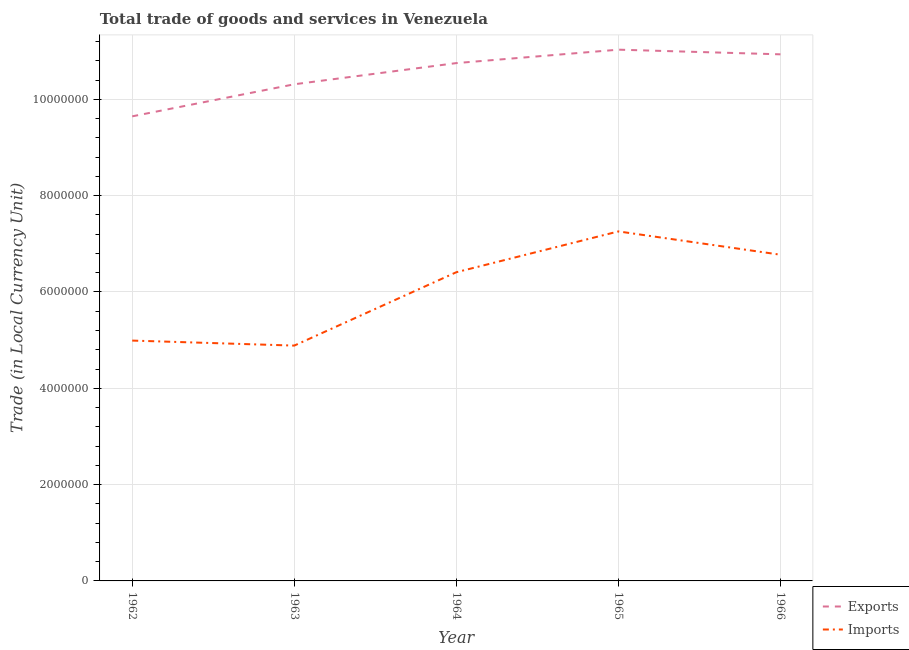Does the line corresponding to export of goods and services intersect with the line corresponding to imports of goods and services?
Your response must be concise. No. What is the export of goods and services in 1965?
Give a very brief answer. 1.10e+07. Across all years, what is the maximum export of goods and services?
Keep it short and to the point. 1.10e+07. Across all years, what is the minimum export of goods and services?
Your answer should be very brief. 9.65e+06. In which year was the export of goods and services maximum?
Your response must be concise. 1965. In which year was the export of goods and services minimum?
Keep it short and to the point. 1962. What is the total export of goods and services in the graph?
Give a very brief answer. 5.27e+07. What is the difference between the imports of goods and services in 1963 and that in 1965?
Provide a succinct answer. -2.37e+06. What is the difference between the imports of goods and services in 1966 and the export of goods and services in 1962?
Give a very brief answer. -2.87e+06. What is the average export of goods and services per year?
Provide a succinct answer. 1.05e+07. In the year 1964, what is the difference between the imports of goods and services and export of goods and services?
Offer a terse response. -4.34e+06. What is the ratio of the imports of goods and services in 1964 to that in 1966?
Provide a succinct answer. 0.95. Is the difference between the export of goods and services in 1962 and 1964 greater than the difference between the imports of goods and services in 1962 and 1964?
Provide a short and direct response. Yes. What is the difference between the highest and the second highest imports of goods and services?
Your response must be concise. 4.84e+05. What is the difference between the highest and the lowest imports of goods and services?
Offer a very short reply. 2.37e+06. In how many years, is the export of goods and services greater than the average export of goods and services taken over all years?
Make the answer very short. 3. Is the imports of goods and services strictly greater than the export of goods and services over the years?
Give a very brief answer. No. Are the values on the major ticks of Y-axis written in scientific E-notation?
Provide a short and direct response. No. Does the graph contain grids?
Your answer should be compact. Yes. What is the title of the graph?
Provide a succinct answer. Total trade of goods and services in Venezuela. What is the label or title of the Y-axis?
Offer a very short reply. Trade (in Local Currency Unit). What is the Trade (in Local Currency Unit) in Exports in 1962?
Give a very brief answer. 9.65e+06. What is the Trade (in Local Currency Unit) in Imports in 1962?
Your answer should be very brief. 4.99e+06. What is the Trade (in Local Currency Unit) of Exports in 1963?
Make the answer very short. 1.03e+07. What is the Trade (in Local Currency Unit) of Imports in 1963?
Your answer should be compact. 4.89e+06. What is the Trade (in Local Currency Unit) of Exports in 1964?
Your response must be concise. 1.08e+07. What is the Trade (in Local Currency Unit) in Imports in 1964?
Your answer should be compact. 6.41e+06. What is the Trade (in Local Currency Unit) in Exports in 1965?
Provide a short and direct response. 1.10e+07. What is the Trade (in Local Currency Unit) of Imports in 1965?
Provide a succinct answer. 7.26e+06. What is the Trade (in Local Currency Unit) in Exports in 1966?
Your answer should be very brief. 1.09e+07. What is the Trade (in Local Currency Unit) of Imports in 1966?
Ensure brevity in your answer.  6.77e+06. Across all years, what is the maximum Trade (in Local Currency Unit) in Exports?
Provide a succinct answer. 1.10e+07. Across all years, what is the maximum Trade (in Local Currency Unit) in Imports?
Your answer should be very brief. 7.26e+06. Across all years, what is the minimum Trade (in Local Currency Unit) of Exports?
Offer a very short reply. 9.65e+06. Across all years, what is the minimum Trade (in Local Currency Unit) of Imports?
Keep it short and to the point. 4.89e+06. What is the total Trade (in Local Currency Unit) of Exports in the graph?
Offer a very short reply. 5.27e+07. What is the total Trade (in Local Currency Unit) of Imports in the graph?
Keep it short and to the point. 3.03e+07. What is the difference between the Trade (in Local Currency Unit) in Exports in 1962 and that in 1963?
Your response must be concise. -6.66e+05. What is the difference between the Trade (in Local Currency Unit) in Imports in 1962 and that in 1963?
Your answer should be very brief. 1.04e+05. What is the difference between the Trade (in Local Currency Unit) in Exports in 1962 and that in 1964?
Provide a succinct answer. -1.11e+06. What is the difference between the Trade (in Local Currency Unit) of Imports in 1962 and that in 1964?
Your answer should be very brief. -1.42e+06. What is the difference between the Trade (in Local Currency Unit) of Exports in 1962 and that in 1965?
Your answer should be compact. -1.38e+06. What is the difference between the Trade (in Local Currency Unit) of Imports in 1962 and that in 1965?
Ensure brevity in your answer.  -2.27e+06. What is the difference between the Trade (in Local Currency Unit) of Exports in 1962 and that in 1966?
Make the answer very short. -1.29e+06. What is the difference between the Trade (in Local Currency Unit) of Imports in 1962 and that in 1966?
Give a very brief answer. -1.78e+06. What is the difference between the Trade (in Local Currency Unit) in Exports in 1963 and that in 1964?
Ensure brevity in your answer.  -4.40e+05. What is the difference between the Trade (in Local Currency Unit) of Imports in 1963 and that in 1964?
Your response must be concise. -1.52e+06. What is the difference between the Trade (in Local Currency Unit) in Exports in 1963 and that in 1965?
Make the answer very short. -7.19e+05. What is the difference between the Trade (in Local Currency Unit) of Imports in 1963 and that in 1965?
Provide a short and direct response. -2.37e+06. What is the difference between the Trade (in Local Currency Unit) in Exports in 1963 and that in 1966?
Keep it short and to the point. -6.22e+05. What is the difference between the Trade (in Local Currency Unit) in Imports in 1963 and that in 1966?
Provide a succinct answer. -1.89e+06. What is the difference between the Trade (in Local Currency Unit) in Exports in 1964 and that in 1965?
Give a very brief answer. -2.79e+05. What is the difference between the Trade (in Local Currency Unit) in Imports in 1964 and that in 1965?
Keep it short and to the point. -8.47e+05. What is the difference between the Trade (in Local Currency Unit) in Exports in 1964 and that in 1966?
Give a very brief answer. -1.82e+05. What is the difference between the Trade (in Local Currency Unit) in Imports in 1964 and that in 1966?
Make the answer very short. -3.63e+05. What is the difference between the Trade (in Local Currency Unit) in Exports in 1965 and that in 1966?
Make the answer very short. 9.68e+04. What is the difference between the Trade (in Local Currency Unit) in Imports in 1965 and that in 1966?
Your response must be concise. 4.84e+05. What is the difference between the Trade (in Local Currency Unit) in Exports in 1962 and the Trade (in Local Currency Unit) in Imports in 1963?
Your answer should be compact. 4.76e+06. What is the difference between the Trade (in Local Currency Unit) of Exports in 1962 and the Trade (in Local Currency Unit) of Imports in 1964?
Your answer should be very brief. 3.24e+06. What is the difference between the Trade (in Local Currency Unit) of Exports in 1962 and the Trade (in Local Currency Unit) of Imports in 1965?
Make the answer very short. 2.39e+06. What is the difference between the Trade (in Local Currency Unit) of Exports in 1962 and the Trade (in Local Currency Unit) of Imports in 1966?
Give a very brief answer. 2.87e+06. What is the difference between the Trade (in Local Currency Unit) of Exports in 1963 and the Trade (in Local Currency Unit) of Imports in 1964?
Give a very brief answer. 3.90e+06. What is the difference between the Trade (in Local Currency Unit) in Exports in 1963 and the Trade (in Local Currency Unit) in Imports in 1965?
Ensure brevity in your answer.  3.06e+06. What is the difference between the Trade (in Local Currency Unit) of Exports in 1963 and the Trade (in Local Currency Unit) of Imports in 1966?
Make the answer very short. 3.54e+06. What is the difference between the Trade (in Local Currency Unit) of Exports in 1964 and the Trade (in Local Currency Unit) of Imports in 1965?
Keep it short and to the point. 3.50e+06. What is the difference between the Trade (in Local Currency Unit) of Exports in 1964 and the Trade (in Local Currency Unit) of Imports in 1966?
Provide a succinct answer. 3.98e+06. What is the difference between the Trade (in Local Currency Unit) in Exports in 1965 and the Trade (in Local Currency Unit) in Imports in 1966?
Ensure brevity in your answer.  4.26e+06. What is the average Trade (in Local Currency Unit) of Exports per year?
Keep it short and to the point. 1.05e+07. What is the average Trade (in Local Currency Unit) in Imports per year?
Provide a succinct answer. 6.06e+06. In the year 1962, what is the difference between the Trade (in Local Currency Unit) in Exports and Trade (in Local Currency Unit) in Imports?
Keep it short and to the point. 4.66e+06. In the year 1963, what is the difference between the Trade (in Local Currency Unit) of Exports and Trade (in Local Currency Unit) of Imports?
Offer a terse response. 5.43e+06. In the year 1964, what is the difference between the Trade (in Local Currency Unit) in Exports and Trade (in Local Currency Unit) in Imports?
Make the answer very short. 4.34e+06. In the year 1965, what is the difference between the Trade (in Local Currency Unit) of Exports and Trade (in Local Currency Unit) of Imports?
Make the answer very short. 3.77e+06. In the year 1966, what is the difference between the Trade (in Local Currency Unit) in Exports and Trade (in Local Currency Unit) in Imports?
Provide a succinct answer. 4.16e+06. What is the ratio of the Trade (in Local Currency Unit) of Exports in 1962 to that in 1963?
Your answer should be very brief. 0.94. What is the ratio of the Trade (in Local Currency Unit) in Imports in 1962 to that in 1963?
Your response must be concise. 1.02. What is the ratio of the Trade (in Local Currency Unit) of Exports in 1962 to that in 1964?
Give a very brief answer. 0.9. What is the ratio of the Trade (in Local Currency Unit) in Imports in 1962 to that in 1964?
Make the answer very short. 0.78. What is the ratio of the Trade (in Local Currency Unit) of Exports in 1962 to that in 1965?
Ensure brevity in your answer.  0.87. What is the ratio of the Trade (in Local Currency Unit) in Imports in 1962 to that in 1965?
Provide a succinct answer. 0.69. What is the ratio of the Trade (in Local Currency Unit) of Exports in 1962 to that in 1966?
Your answer should be very brief. 0.88. What is the ratio of the Trade (in Local Currency Unit) in Imports in 1962 to that in 1966?
Offer a terse response. 0.74. What is the ratio of the Trade (in Local Currency Unit) of Exports in 1963 to that in 1964?
Offer a very short reply. 0.96. What is the ratio of the Trade (in Local Currency Unit) of Imports in 1963 to that in 1964?
Offer a very short reply. 0.76. What is the ratio of the Trade (in Local Currency Unit) in Exports in 1963 to that in 1965?
Offer a terse response. 0.93. What is the ratio of the Trade (in Local Currency Unit) in Imports in 1963 to that in 1965?
Your answer should be very brief. 0.67. What is the ratio of the Trade (in Local Currency Unit) of Exports in 1963 to that in 1966?
Offer a very short reply. 0.94. What is the ratio of the Trade (in Local Currency Unit) in Imports in 1963 to that in 1966?
Give a very brief answer. 0.72. What is the ratio of the Trade (in Local Currency Unit) of Exports in 1964 to that in 1965?
Your answer should be compact. 0.97. What is the ratio of the Trade (in Local Currency Unit) in Imports in 1964 to that in 1965?
Offer a terse response. 0.88. What is the ratio of the Trade (in Local Currency Unit) in Exports in 1964 to that in 1966?
Your answer should be very brief. 0.98. What is the ratio of the Trade (in Local Currency Unit) of Imports in 1964 to that in 1966?
Offer a terse response. 0.95. What is the ratio of the Trade (in Local Currency Unit) in Exports in 1965 to that in 1966?
Offer a very short reply. 1.01. What is the ratio of the Trade (in Local Currency Unit) of Imports in 1965 to that in 1966?
Offer a very short reply. 1.07. What is the difference between the highest and the second highest Trade (in Local Currency Unit) of Exports?
Ensure brevity in your answer.  9.68e+04. What is the difference between the highest and the second highest Trade (in Local Currency Unit) of Imports?
Keep it short and to the point. 4.84e+05. What is the difference between the highest and the lowest Trade (in Local Currency Unit) of Exports?
Your answer should be very brief. 1.38e+06. What is the difference between the highest and the lowest Trade (in Local Currency Unit) of Imports?
Keep it short and to the point. 2.37e+06. 